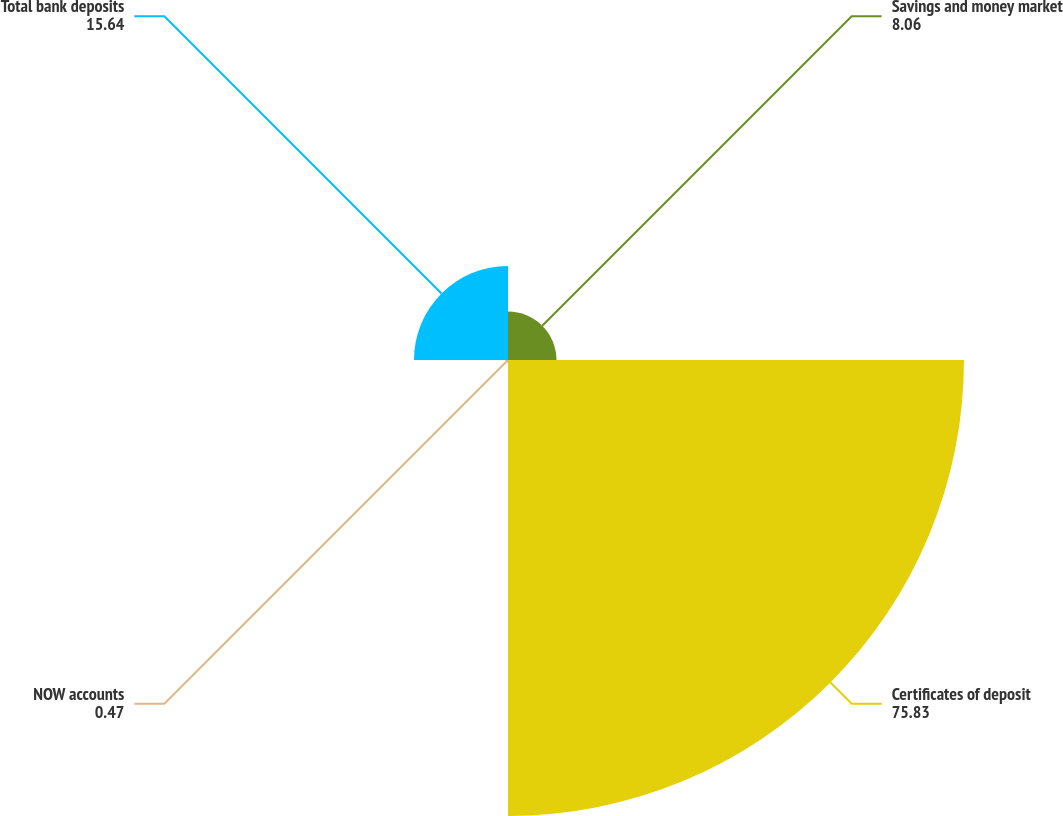Convert chart. <chart><loc_0><loc_0><loc_500><loc_500><pie_chart><fcel>Savings and money market<fcel>Certificates of deposit<fcel>NOW accounts<fcel>Total bank deposits<nl><fcel>8.06%<fcel>75.83%<fcel>0.47%<fcel>15.64%<nl></chart> 